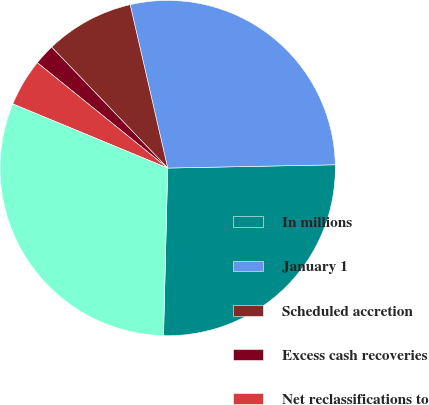<chart> <loc_0><loc_0><loc_500><loc_500><pie_chart><fcel>In millions<fcel>January 1<fcel>Scheduled accretion<fcel>Excess cash recoveries<fcel>Net reclassifications to<fcel>December 31 (b)<nl><fcel>25.71%<fcel>28.28%<fcel>8.58%<fcel>2.01%<fcel>4.57%<fcel>30.85%<nl></chart> 